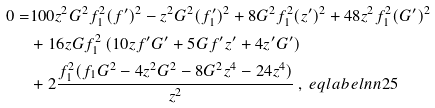Convert formula to latex. <formula><loc_0><loc_0><loc_500><loc_500>0 = & 1 0 0 z ^ { 2 } G ^ { 2 } f _ { 1 } ^ { 2 } ( f ^ { \prime } ) ^ { 2 } - z ^ { 2 } G ^ { 2 } ( f _ { 1 } ^ { \prime } ) ^ { 2 } + 8 G ^ { 2 } f _ { 1 } ^ { 2 } ( z ^ { \prime } ) ^ { 2 } + 4 8 z ^ { 2 } f _ { 1 } ^ { 2 } ( G ^ { \prime } ) ^ { 2 } \\ & + 1 6 z G f _ { 1 } ^ { 2 } \left ( 1 0 z f ^ { \prime } G ^ { \prime } + 5 G f ^ { \prime } z ^ { \prime } + 4 z ^ { \prime } G ^ { \prime } \right ) \\ & + 2 \frac { f _ { 1 } ^ { 2 } ( f _ { 1 } G ^ { 2 } - 4 z ^ { 2 } G ^ { 2 } - 8 G ^ { 2 } z ^ { 4 } - 2 4 z ^ { 4 } ) } { z ^ { 2 } } \, , \ e q l a b e l { n n 2 5 }</formula> 